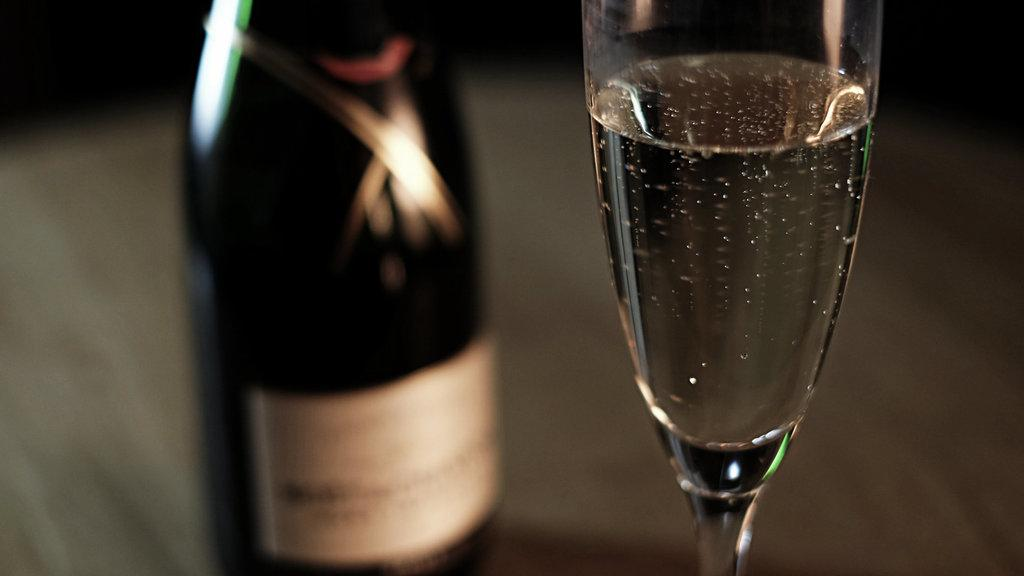What is the color of the bottle in the image? The bottle in the image is black. What else can be seen in the image besides the bottle? There is a glass in the image. What is inside the glass? There is liquid in the glass. Can you describe the background of the image? The background of the image is blurred. Is there a spade being used to stir the liquid in the glass? There is no spade present in the image, and the liquid in the glass is not being stirred. 